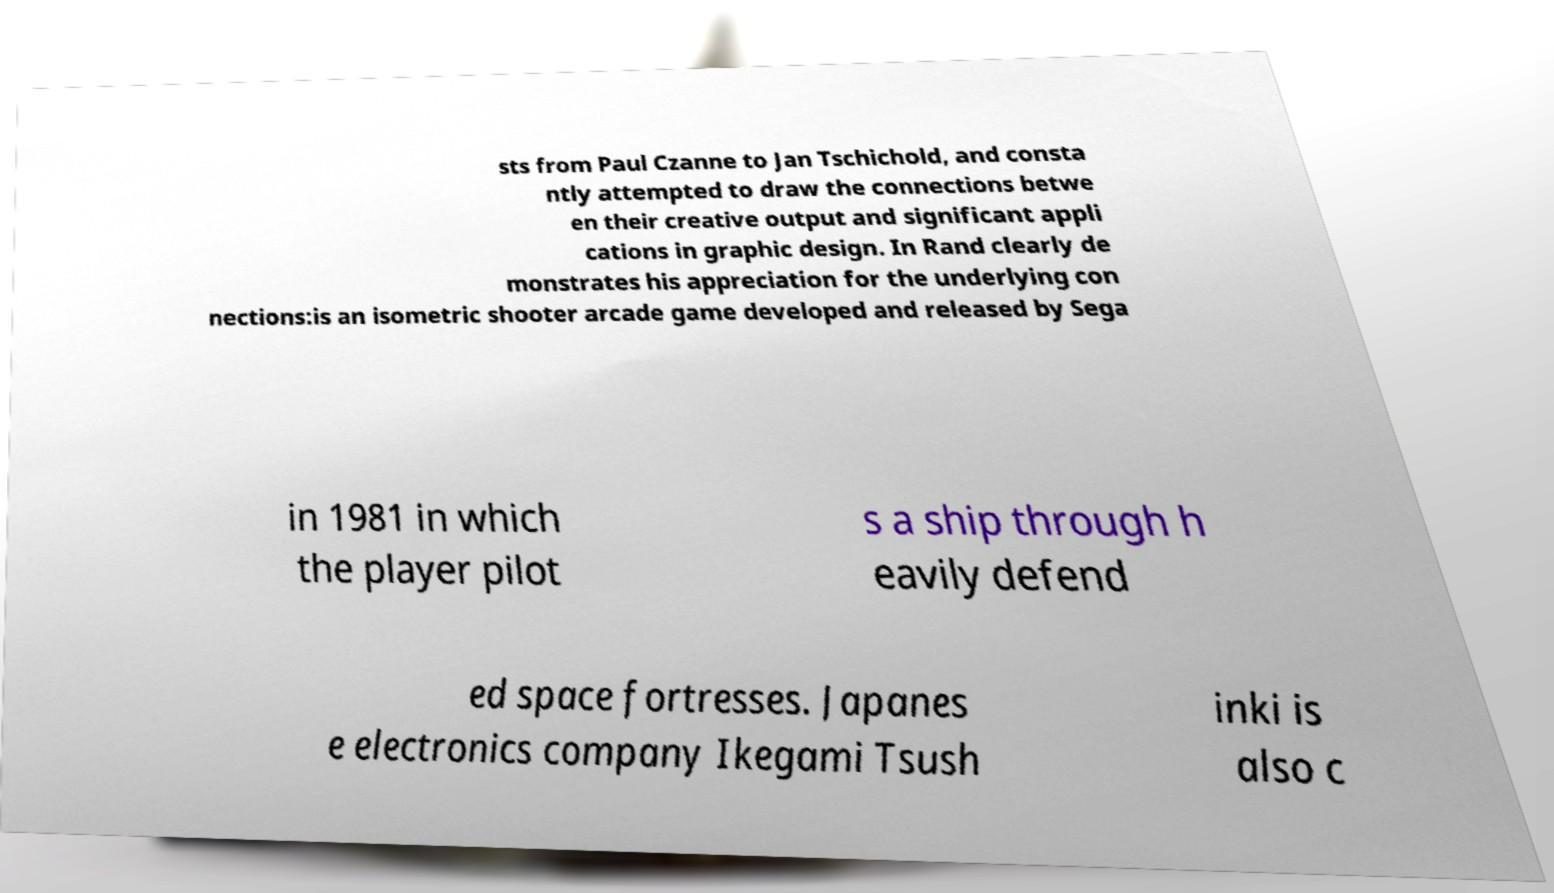For documentation purposes, I need the text within this image transcribed. Could you provide that? sts from Paul Czanne to Jan Tschichold, and consta ntly attempted to draw the connections betwe en their creative output and significant appli cations in graphic design. In Rand clearly de monstrates his appreciation for the underlying con nections:is an isometric shooter arcade game developed and released by Sega in 1981 in which the player pilot s a ship through h eavily defend ed space fortresses. Japanes e electronics company Ikegami Tsush inki is also c 